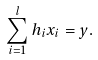<formula> <loc_0><loc_0><loc_500><loc_500>\sum _ { i = 1 } ^ { l } h _ { i } x _ { i } = y .</formula> 